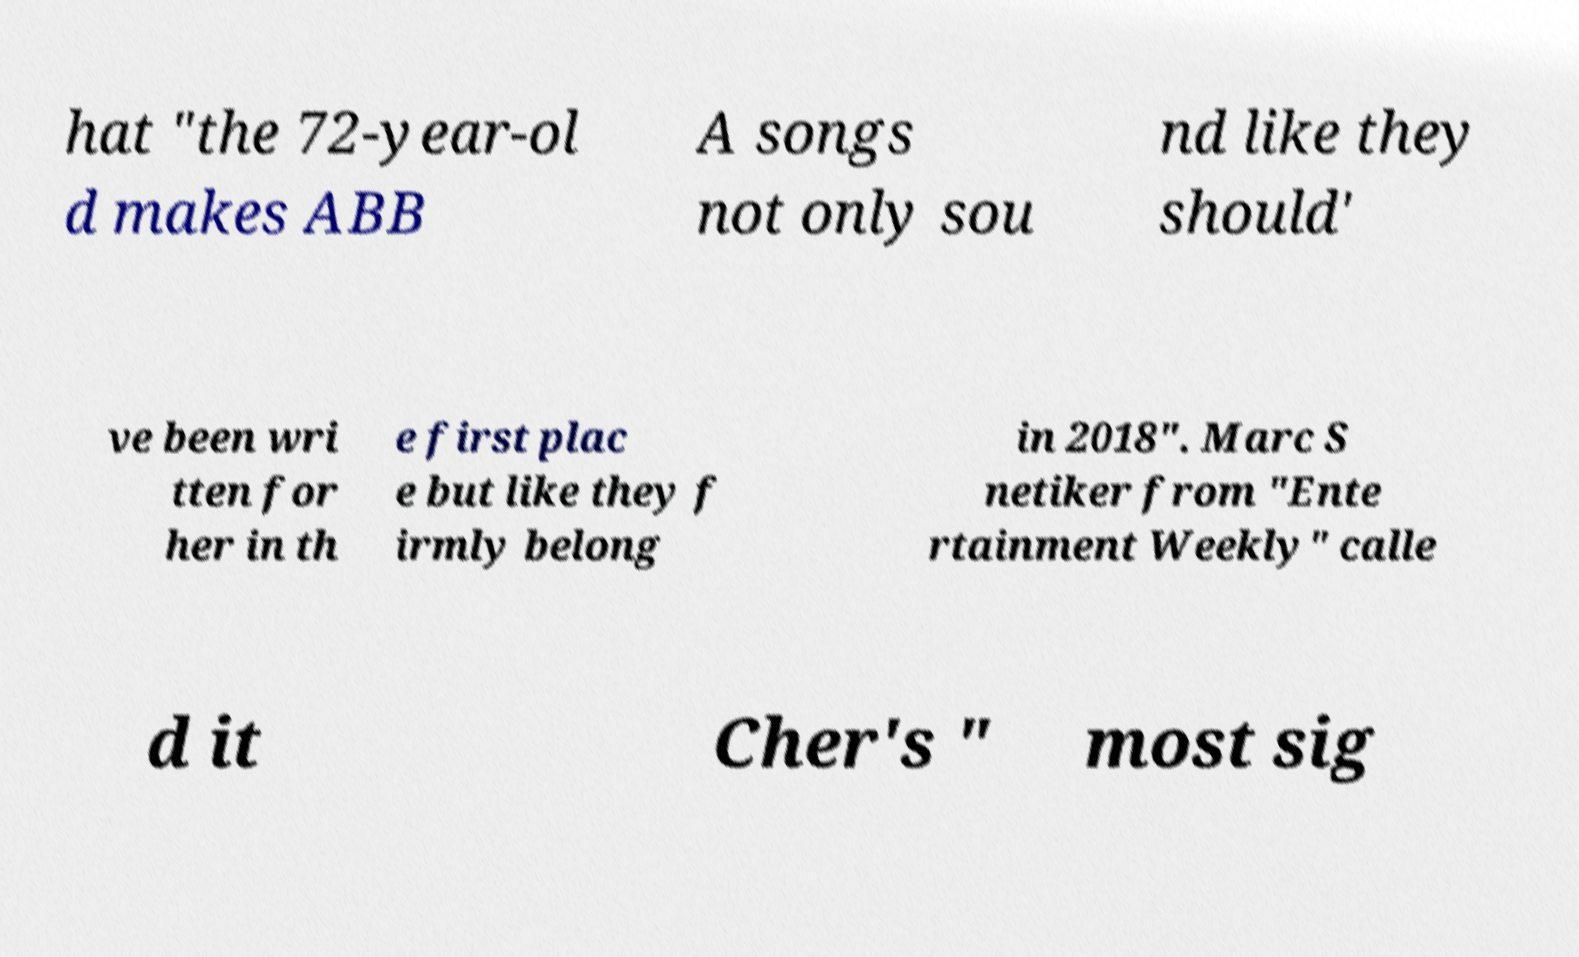Could you extract and type out the text from this image? hat "the 72-year-ol d makes ABB A songs not only sou nd like they should' ve been wri tten for her in th e first plac e but like they f irmly belong in 2018". Marc S netiker from "Ente rtainment Weekly" calle d it Cher's " most sig 